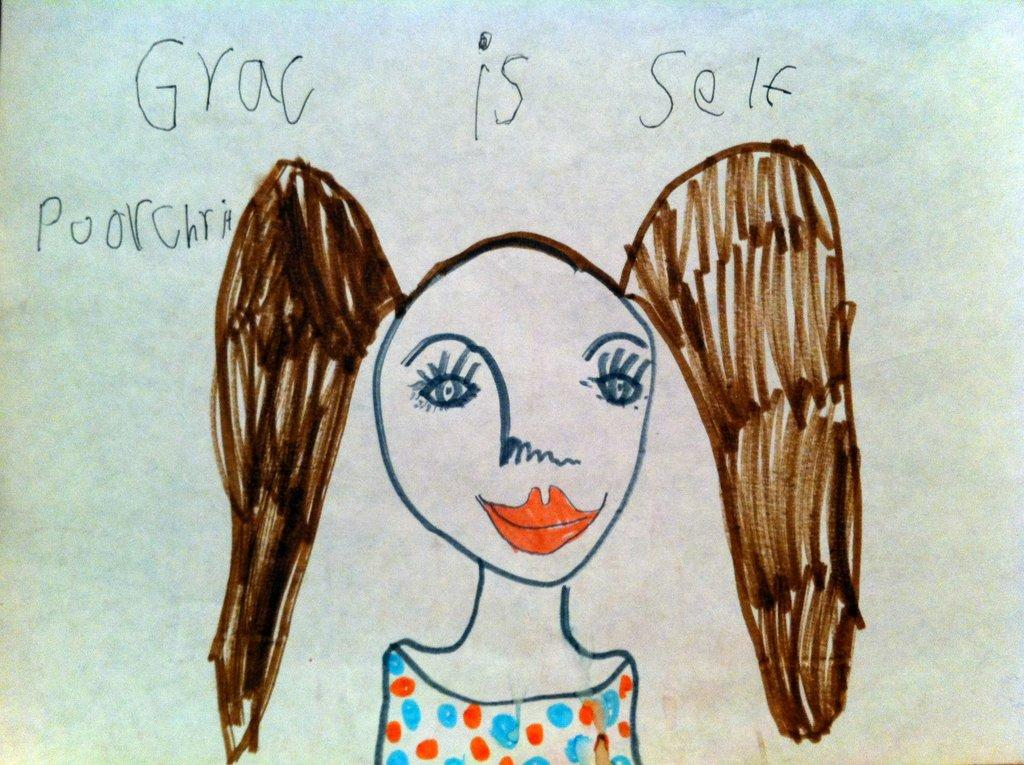What is the main subject of the image? The main subject of the image is a picture of a girl. What else can be seen in the image besides the girl? There is text on a paper in the image. What type of plantation is visible in the image? There is no plantation present in the image; it features a picture of a girl and text on a paper. 